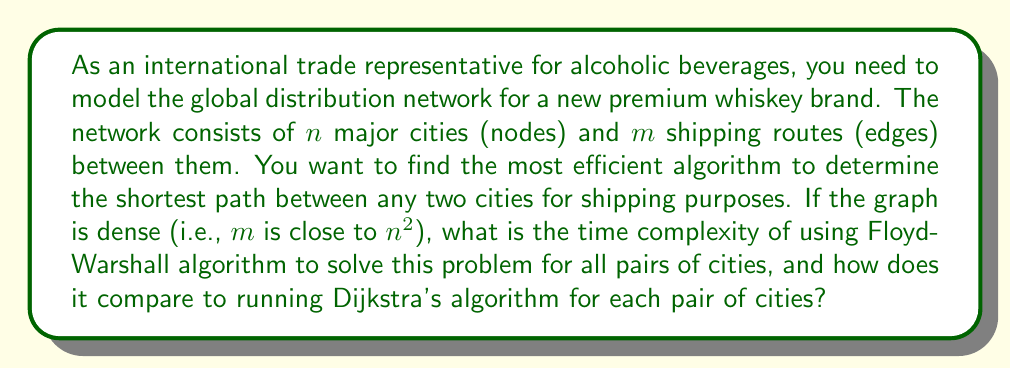Solve this math problem. To solve this problem, we need to consider the time complexities of both Floyd-Warshall algorithm and Dijkstra's algorithm:

1. Floyd-Warshall algorithm:
   - Time complexity: $O(n^3)$
   - This algorithm finds the shortest paths between all pairs of vertices in a single execution.

2. Dijkstra's algorithm:
   - Time complexity for a single source: $O((n + m) \log n)$ using a binary heap
   - For all pairs, we need to run it $n$ times, one for each source vertex

For a dense graph, where $m$ is close to $n^2$, we can simplify Dijkstra's time complexity:
$$O((n + m) \log n) \approx O((n + n^2) \log n) = O(n^2 \log n)$$

To find all pairs using Dijkstra's algorithm, we multiply this by $n$:
$$O(n \cdot n^2 \log n) = O(n^3 \log n)$$

Comparing the two:
- Floyd-Warshall: $O(n^3)$
- Dijkstra's for all pairs: $O(n^3 \log n)$

We can see that for dense graphs, Floyd-Warshall algorithm has a better time complexity, as it doesn't have the additional $\log n$ factor.

In the context of modeling global distribution networks for alcoholic beverages, where the number of major cities (nodes) can be large, and many shipping routes (edges) exist between them, Floyd-Warshall algorithm would be more efficient for finding the shortest paths between all pairs of cities.
Answer: For a dense graph with $n$ nodes, Floyd-Warshall algorithm has a time complexity of $O(n^3)$, which is more efficient than running Dijkstra's algorithm for all pairs, which has a time complexity of $O(n^3 \log n)$. 